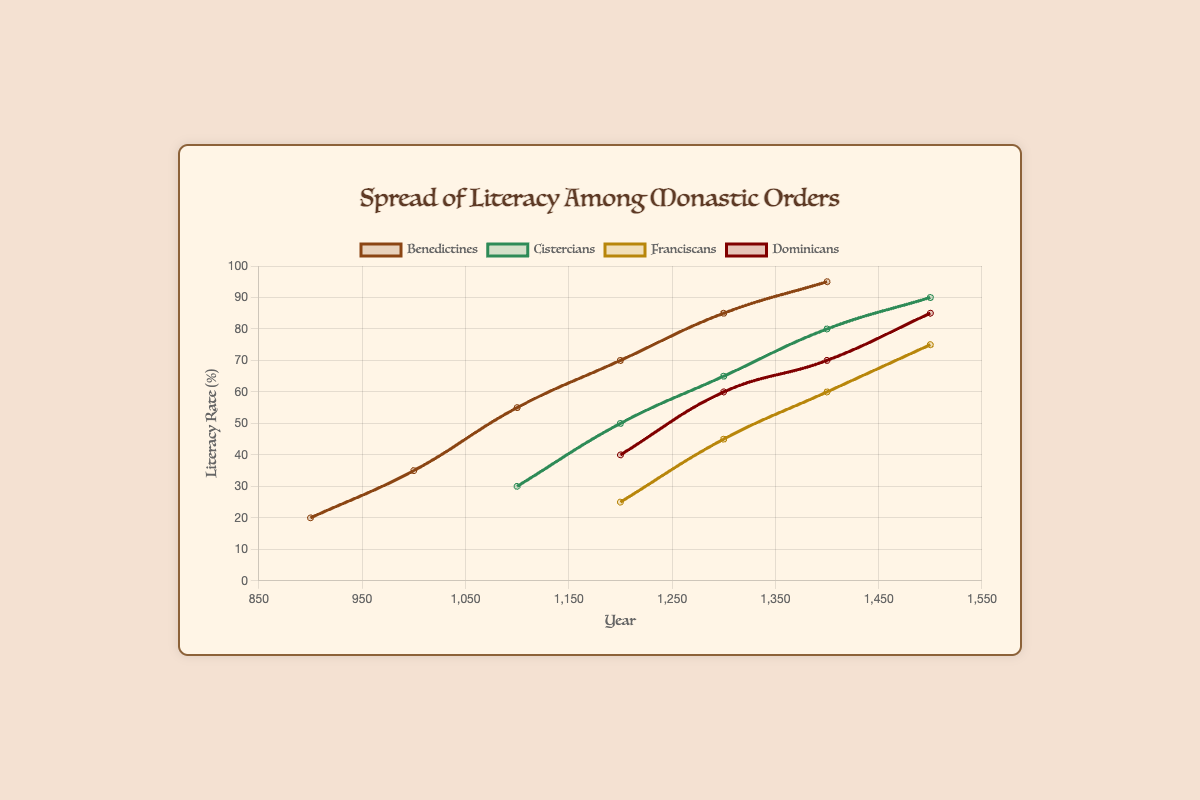Which monastic order had the highest literacy rate in the year 1300? In the year 1300, the Benedictines had a literacy rate of 85%, the Cistercians had a rate of 65%, the Franciscans had a rate of 45%, and the Dominicans had a rate of 60%. The highest rate among these values is 85%.
Answer: Benedictines What is the difference in literacy rate between the Cistercians and Franciscans in the year 1400? In the year 1400, the literacy rate for the Cistercians is 80%, and for the Franciscans, it is 60%. The difference between these rates is 80% - 60% = 20%.
Answer: 20% Which two orders had an equal or greater literacy rate than the Dominicans in 1200? In the year 1200, the Dominicans had a literacy rate of 40%. The Benedictines had a rate of 70%, the Cistercians had a rate of 50%, and the Franciscans had a rate of 25%. Only the Benedictines and Cistercians had a rate equal or higher than 40%.
Answer: Benedictines, Cistercians What was the average literacy rate of the Benedictines, Cistercians, and Franciscans in the year 1200? In the year 1200, the literacy rate for Benedictines was 70%, for Cistercians was 50%, and for Franciscans was 25%. The average is calculated as (70% + 50% + 25%) / 3 = 145% / 3 ≈ 48.33%.
Answer: 48.33% By how much did the literacy rate of the Benedictines increase from the year 900 to 1400? The literacy rate for the Benedictines in the year 900 was 20%, and in 1400 it was 95%. The increase is calculated as 95% - 20% = 75%.
Answer: 75% Which order had the smallest increase in literacy rate from 1200 to 1500? From 1200 to 1500, the Benedictines' rate increased from 70% to 95% (25%), Cistercians from 50% to 90% (40%), Franciscans from 25% to 75% (50%), and Dominicans from 40% to 85% (45%). The smallest increase is 25% by the Benedictines.
Answer: Benedictines Compare the trend of the literacy rates of the Cistercians and the Dominicans between the years 1100 and 1500. Between 1100 and 1500, the literacy rate for Cistercians rises from 30% to 90%. For Dominicans, the literacy rate rises from 40% to 85% between 1200 and 1500. Both orders show an increasing trend, but the Cistercians consistently increase from 1100, whereas Dominicans start from 1200.
Answer: Both increasing, but Cistercians start earlier What is the overall trend of literacy rates for all monastic orders from the year 900 to 1500? From 900 to 1500, all monastic orders show an overall increasing trend in literacy rates. The Benedictines start at 20% in 900 and reach 95% by 1500. The Cistercians, Franciscans, and Dominicans also show similar upward trends starting at different points but all rising over the centuries.
Answer: Increasing trend overall 